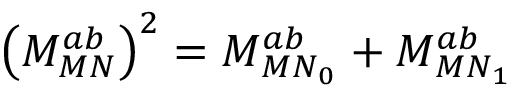<formula> <loc_0><loc_0><loc_500><loc_500>\left ( M _ { M N } ^ { a b } \right ) ^ { 2 } = M _ { { M N } _ { 0 } } ^ { a b } + M _ { { M N } _ { 1 } } ^ { a b }</formula> 